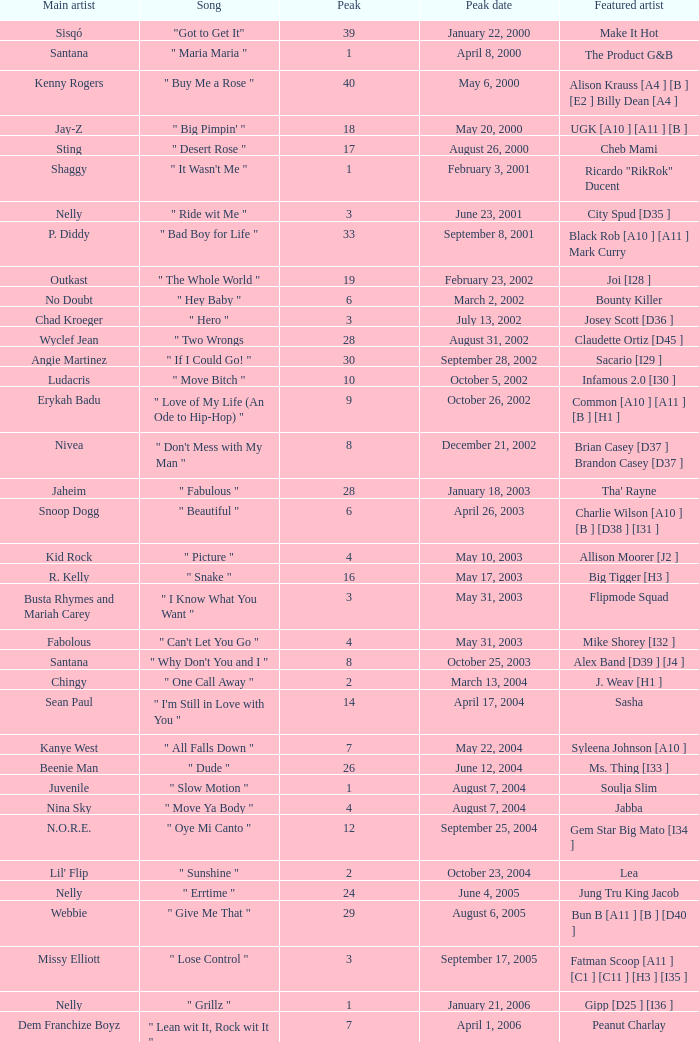What was the peak date of Kelis's song? August 6, 2006. 